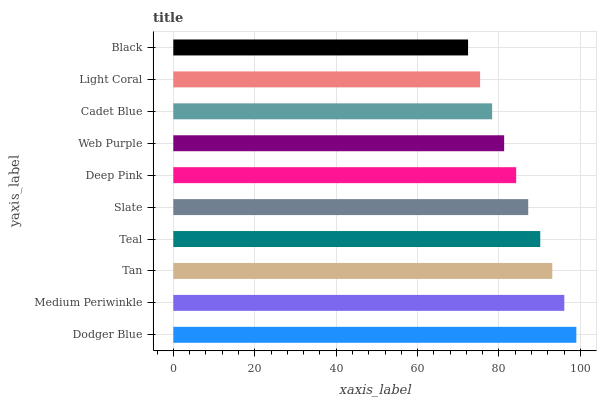Is Black the minimum?
Answer yes or no. Yes. Is Dodger Blue the maximum?
Answer yes or no. Yes. Is Medium Periwinkle the minimum?
Answer yes or no. No. Is Medium Periwinkle the maximum?
Answer yes or no. No. Is Dodger Blue greater than Medium Periwinkle?
Answer yes or no. Yes. Is Medium Periwinkle less than Dodger Blue?
Answer yes or no. Yes. Is Medium Periwinkle greater than Dodger Blue?
Answer yes or no. No. Is Dodger Blue less than Medium Periwinkle?
Answer yes or no. No. Is Slate the high median?
Answer yes or no. Yes. Is Deep Pink the low median?
Answer yes or no. Yes. Is Teal the high median?
Answer yes or no. No. Is Medium Periwinkle the low median?
Answer yes or no. No. 